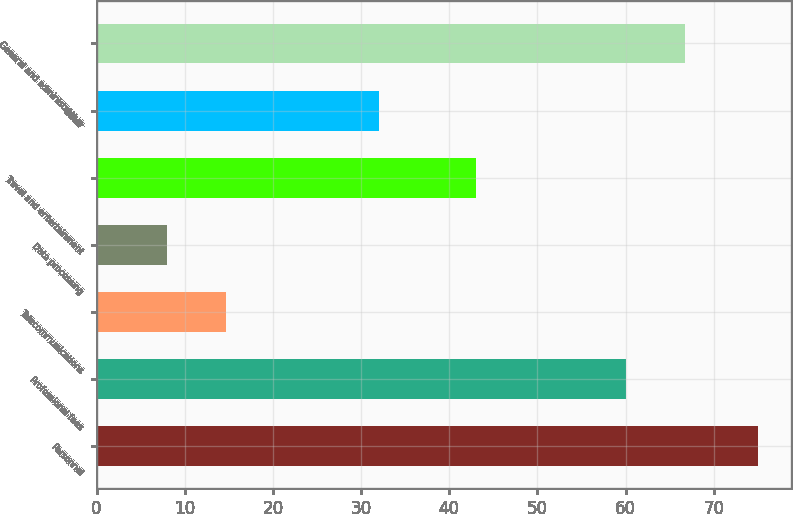Convert chart. <chart><loc_0><loc_0><loc_500><loc_500><bar_chart><fcel>Personnel<fcel>Professional fees<fcel>Telecommunications<fcel>Data processing<fcel>Travel and entertainment<fcel>Other<fcel>General and administrative<nl><fcel>75<fcel>60<fcel>14.7<fcel>8<fcel>43<fcel>32<fcel>66.7<nl></chart> 